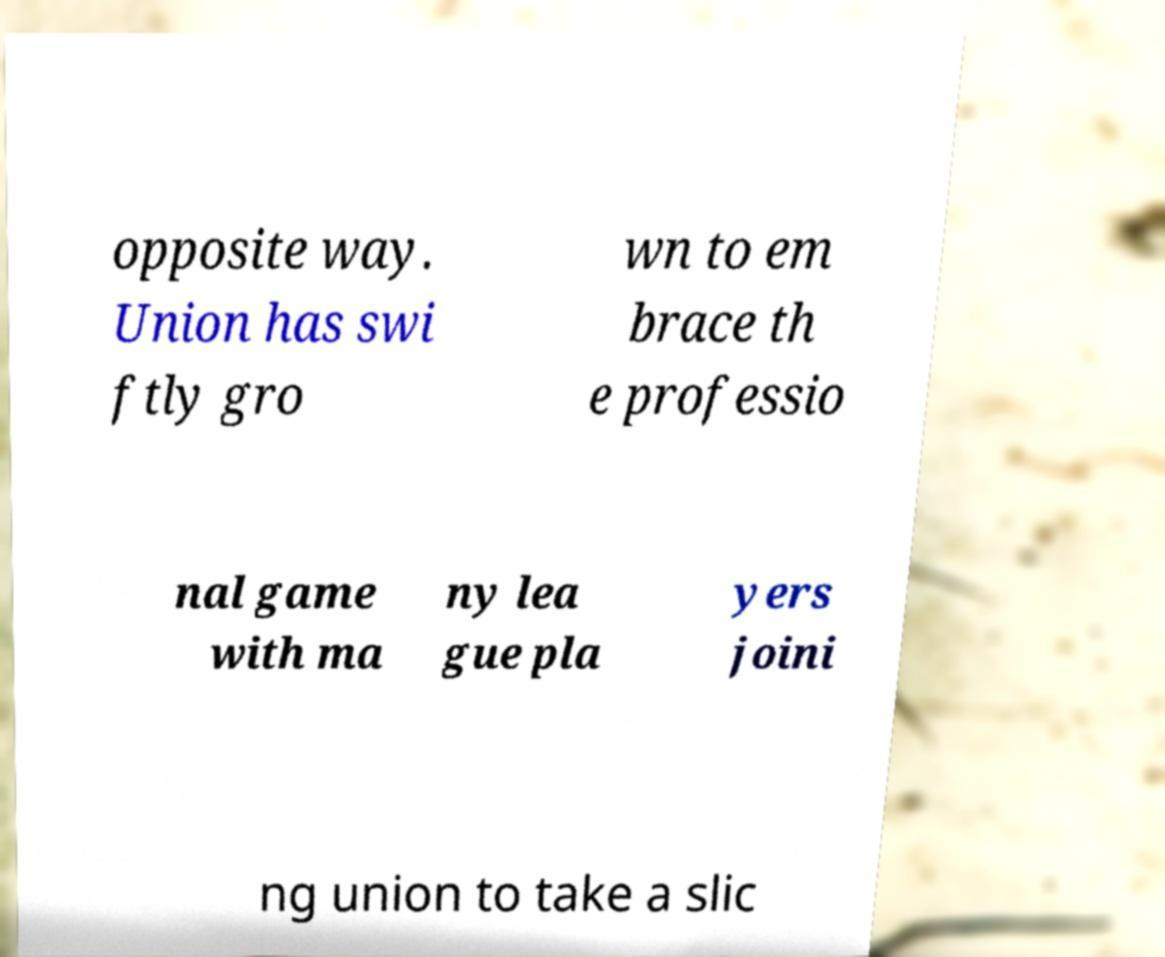Could you assist in decoding the text presented in this image and type it out clearly? opposite way. Union has swi ftly gro wn to em brace th e professio nal game with ma ny lea gue pla yers joini ng union to take a slic 